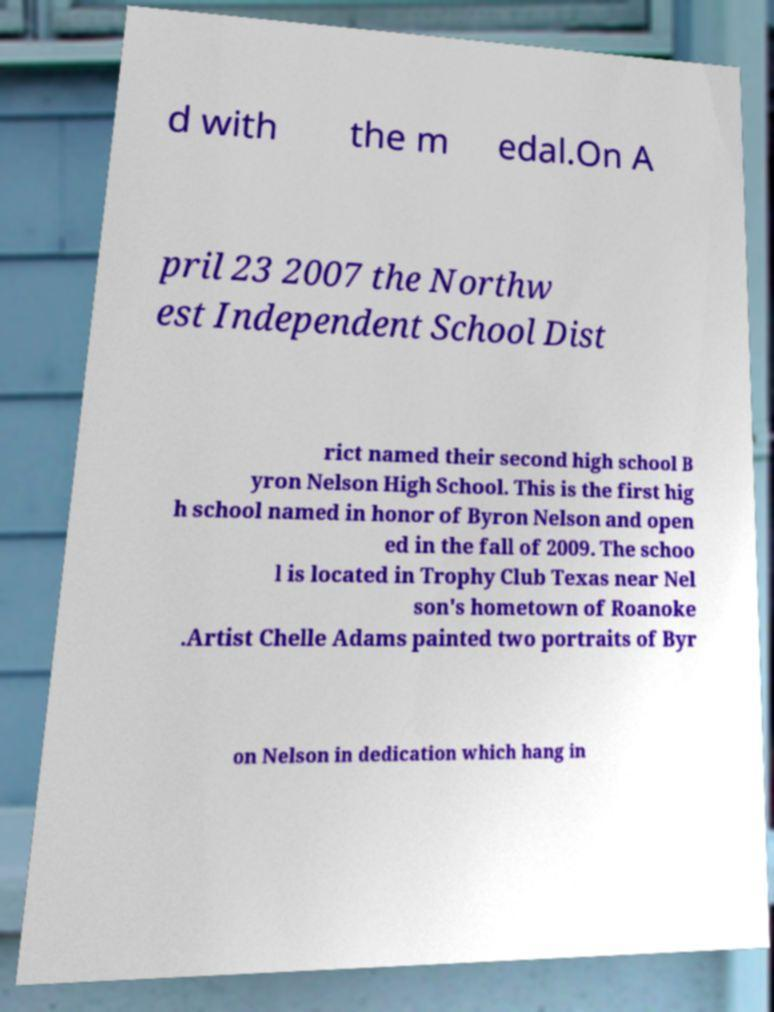Please read and relay the text visible in this image. What does it say? d with the m edal.On A pril 23 2007 the Northw est Independent School Dist rict named their second high school B yron Nelson High School. This is the first hig h school named in honor of Byron Nelson and open ed in the fall of 2009. The schoo l is located in Trophy Club Texas near Nel son's hometown of Roanoke .Artist Chelle Adams painted two portraits of Byr on Nelson in dedication which hang in 